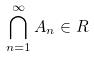Convert formula to latex. <formula><loc_0><loc_0><loc_500><loc_500>\bigcap _ { n = 1 } ^ { \infty } A _ { n } \in R</formula> 